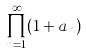<formula> <loc_0><loc_0><loc_500><loc_500>\prod _ { n = 1 } ^ { \infty } ( 1 + a _ { n } )</formula> 